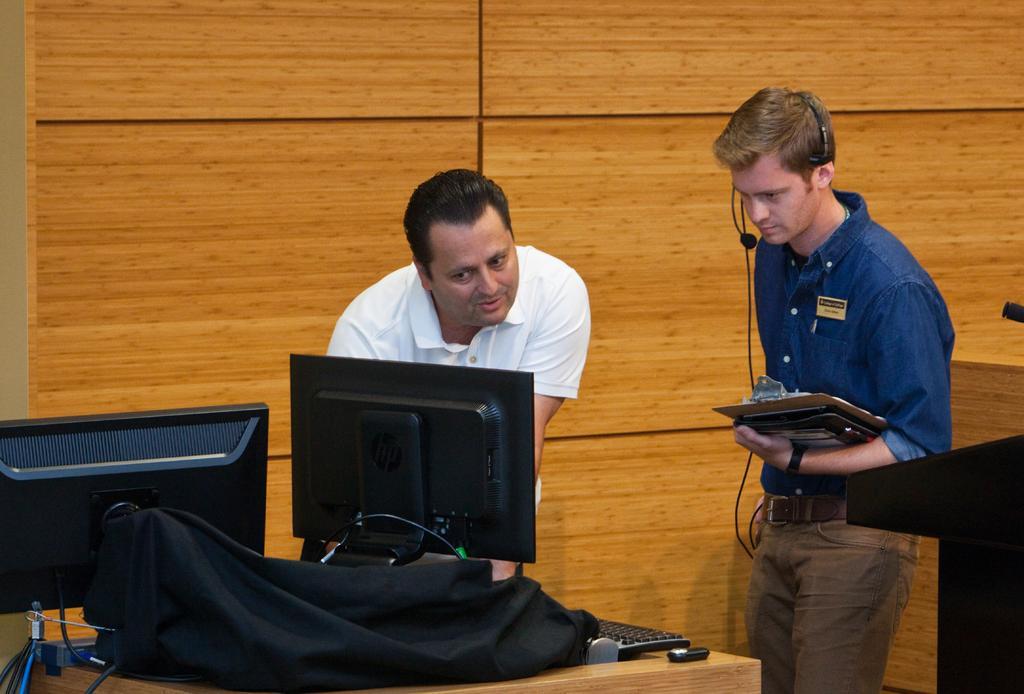Describe this image in one or two sentences. In this picture we can see two men standing and one is looking at monitor and other talking on mic carrying writing pad in hands and in front of them on table we have keyboard, bag, wires and in the background we can see wall. 